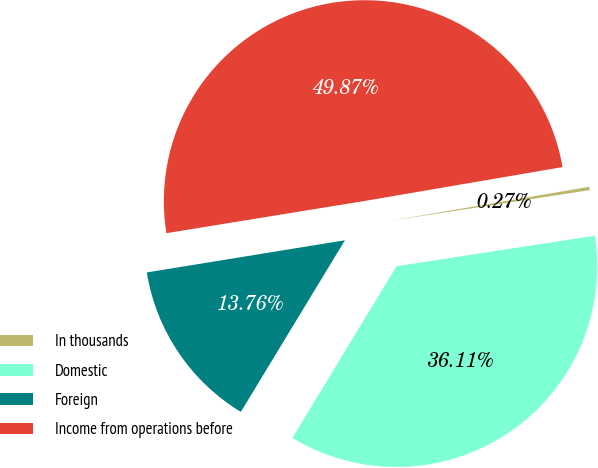Convert chart to OTSL. <chart><loc_0><loc_0><loc_500><loc_500><pie_chart><fcel>In thousands<fcel>Domestic<fcel>Foreign<fcel>Income from operations before<nl><fcel>0.27%<fcel>36.11%<fcel>13.76%<fcel>49.87%<nl></chart> 